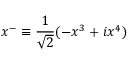Convert formula to latex. <formula><loc_0><loc_0><loc_500><loc_500>x ^ { - } \equiv \frac { 1 } { \sqrt { 2 } } ( - x ^ { 3 } + i x ^ { 4 } )</formula> 